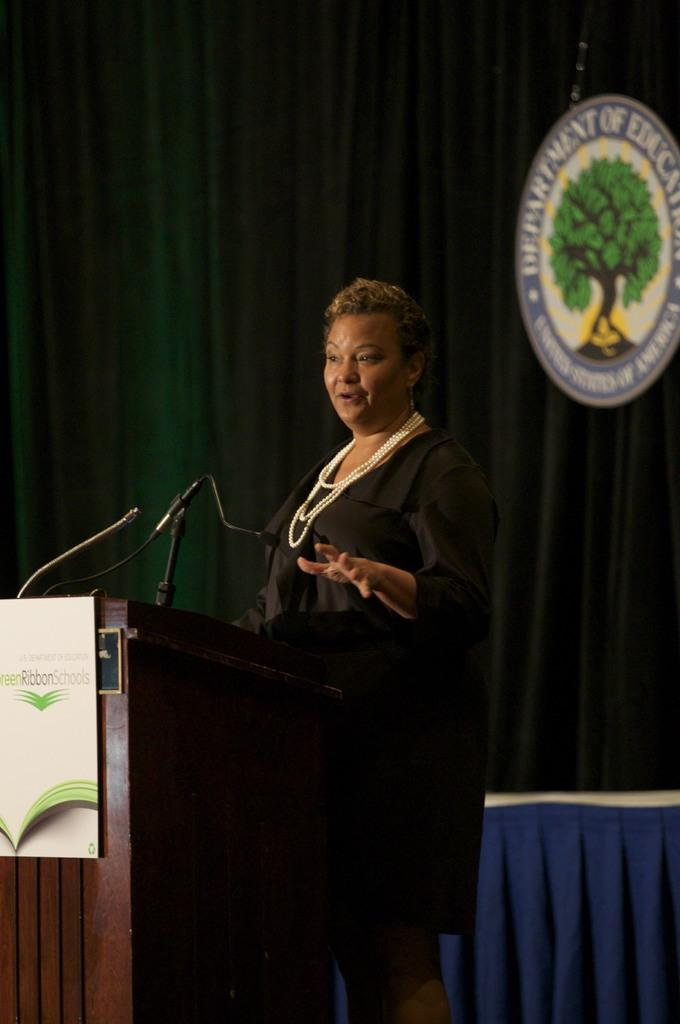What is the lady doing in the image? The lady is standing on the stage. What is placed in front of the lady on the stage? There is a table in front of the lady. What is on the table? There is a microphone (mike) on the table. What can be seen in the background of the image? There are curtains and a logo in the background. What type of insurance policy is being advertised by the geese in the background? There are no geese present in the image, and therefore no insurance policy is being advertised. 